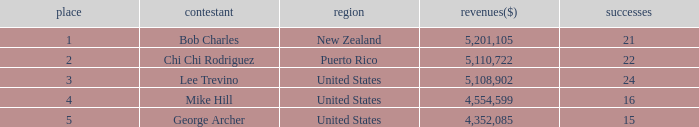Can you give me this table as a dict? {'header': ['place', 'contestant', 'region', 'revenues($)', 'successes'], 'rows': [['1', 'Bob Charles', 'New Zealand', '5,201,105', '21'], ['2', 'Chi Chi Rodriguez', 'Puerto Rico', '5,110,722', '22'], ['3', 'Lee Trevino', 'United States', '5,108,902', '24'], ['4', 'Mike Hill', 'United States', '4,554,599', '16'], ['5', 'George Archer', 'United States', '4,352,085', '15']]} On average, how many wins have a rank lower than 1? None. 